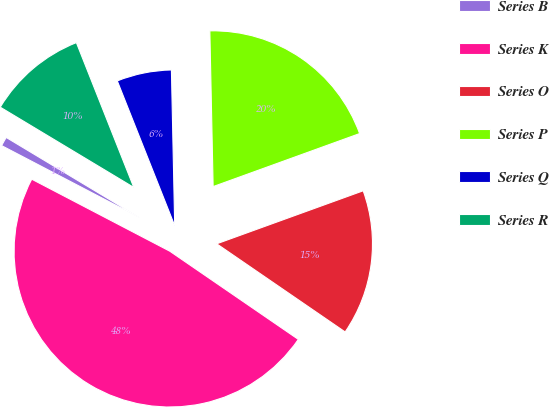Convert chart. <chart><loc_0><loc_0><loc_500><loc_500><pie_chart><fcel>Series B<fcel>Series K<fcel>Series O<fcel>Series P<fcel>Series Q<fcel>Series R<nl><fcel>0.96%<fcel>48.08%<fcel>15.1%<fcel>19.81%<fcel>5.67%<fcel>10.38%<nl></chart> 